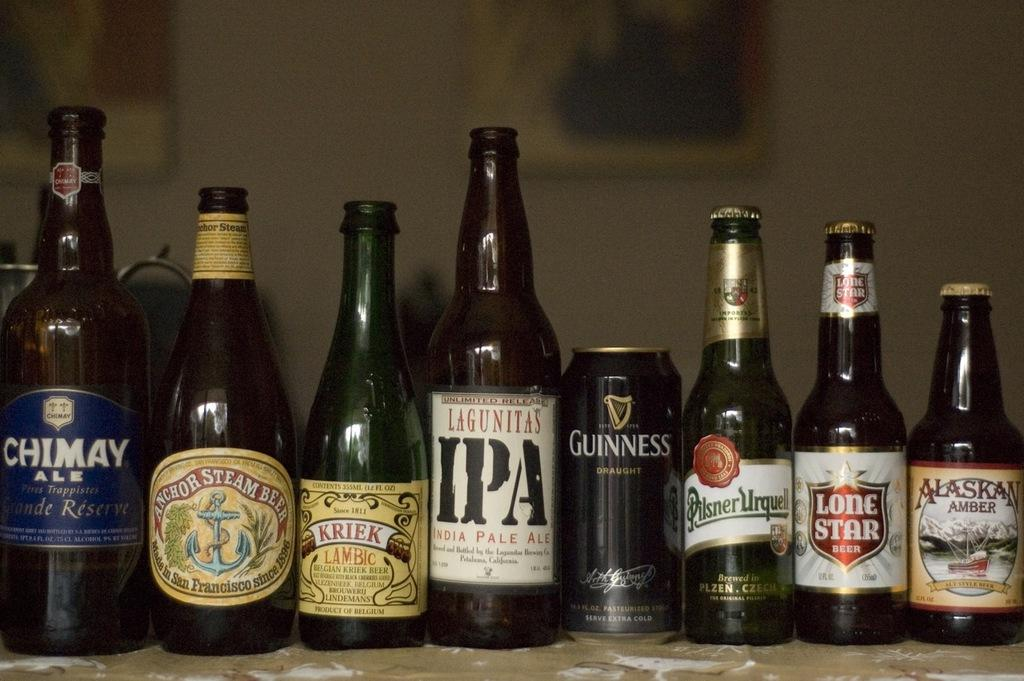<image>
Summarize the visual content of the image. a variation of beers that include kriek lagunitas and guiness 